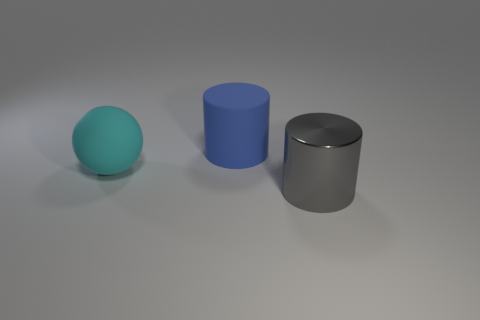Add 3 blue matte cylinders. How many objects exist? 6 Subtract all cylinders. How many objects are left? 1 Subtract all big red shiny things. Subtract all large matte objects. How many objects are left? 1 Add 2 big cyan rubber balls. How many big cyan rubber balls are left? 3 Add 3 big rubber things. How many big rubber things exist? 5 Subtract 0 brown cubes. How many objects are left? 3 Subtract all blue balls. Subtract all cyan cylinders. How many balls are left? 1 